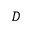<formula> <loc_0><loc_0><loc_500><loc_500>{ D }</formula> 